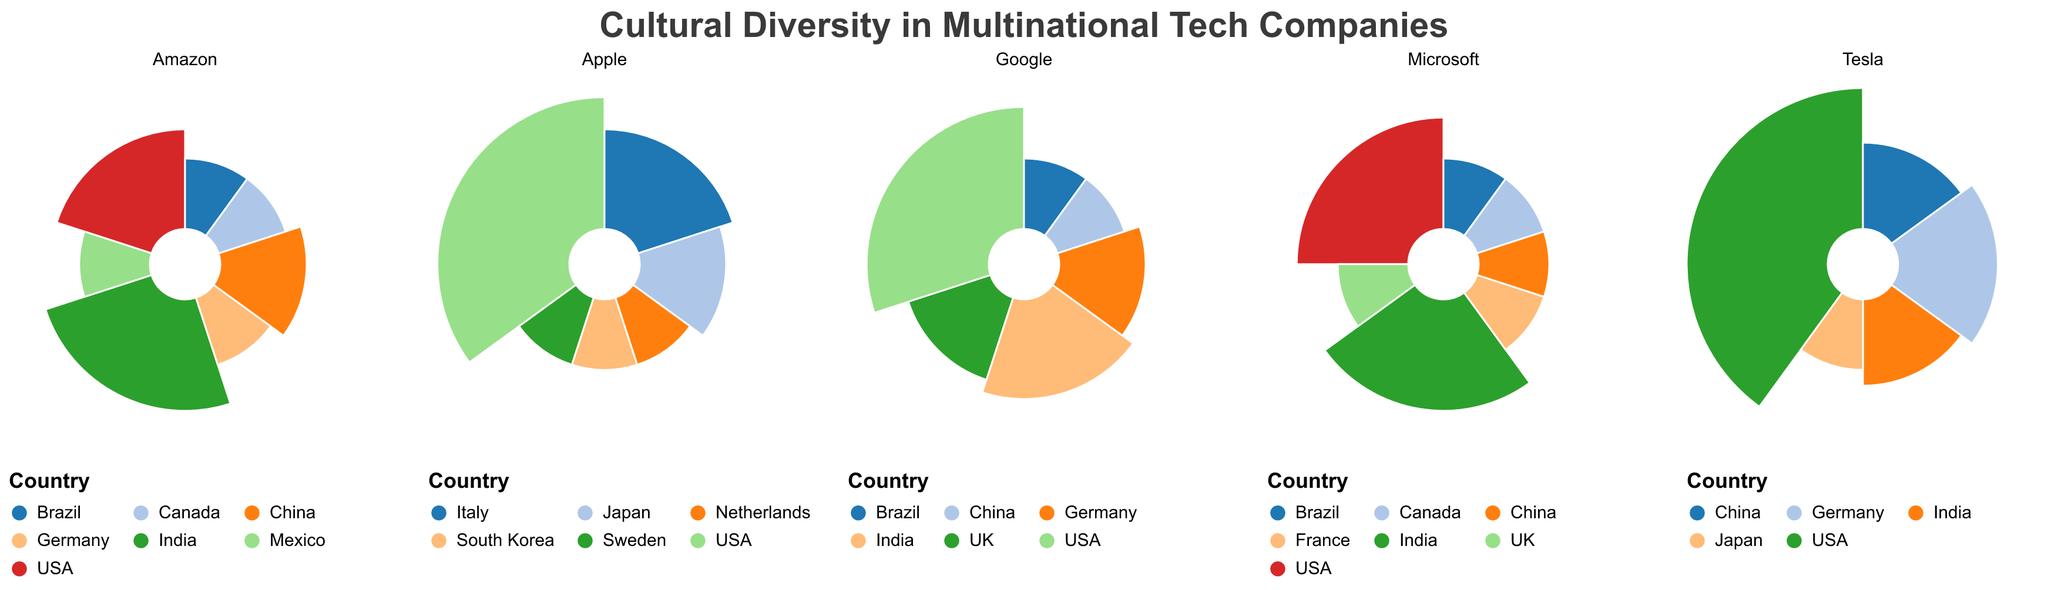What are the different cultural backgrounds represented in Google's Engineering team? The Polar Chart displays segments corresponding to each cultural background in Google's Engineering team. These include contributions from the USA, India, China, Brazil, the UK, and Germany.
Answer: USA, India, China, Brazil, UK, Germany Which company has the highest percentage contribution from the USA? In the Polar Chart, Tesla's Development team has the largest arc segment for the USA, contributing 40%. A simple comparison with the other companies' USA segments confirms this.
Answer: Tesla What is the combined percentage contribution of China and India in Apple's Design team? The chart shows the percentage contributions from China and India in Apple's Design team as 15% and 15% respectively. Adding these values gives the total contribution. 15% + 15% = 30%
Answer: 30% Which company shows a more evenly distributed contribution among different cultural backgrounds, Amazon's Logistics or Microsoft's Research team? By visually inspecting the Polar Charts, Amazon's Logistics shows more segments with smaller and relatively even sizes compared to Microsoft's Research, which has larger contributions from the USA and India, and smaller from other countries.
Answer: Amazon Identify the company and team with the lowest cultural diversity. Tesla's Development team shows a high percentage from the USA (40%), indicating a lower cultural diversity compared to others with smaller and more varied segments.
Answer: Tesla What proportion of Google's Engineering team is made up of contributions from countries other than the USA? Google’s Engineering team consists of 30% from the USA. Subtracting this from 100%, we find 100% - 30% = 70%.
Answer: 70% By how much does the USA's contribution in Amazon's Logistics team exceed that in Microsoft's Research team? The chart shows Amazon's Logistics team has a 20% contribution from the USA, while Microsoft's Research team has 25%. The difference is 25% - 20% = 5%.
Answer: 5% How does the percentage contribution from Germany in Tesla's Development team compare to Google's Engineering team? Looking at the chart, Germany contributes 20% to Tesla's Development team and 15% to Google's Engineering team. Tesla's is higher by 5%, as 20% - 15% = 5%.
Answer: Tesla's is higher by 5% What is the average percentage contribution per country in Apple's Design team? Apple's Design team has six countries with contributions of 35%, 20%, 15%, 10%, 10%, and 10%. Adding these together, 35 + 20 + 15 + 10 + 10 + 10 = 100%, and dividing by six gives an average of 100/6 ≈ 16.67%.
Answer: 16.67% Which two companies have contributions from all represented countries totaling exactly 100%? All companies in the dataset represent totals of 100%, but Apple's Design and Microsoft's Research are easier to distinguish as having even contributions that sum to exactly 100% based on the prominent and varied segments in their charts.
Answer: Apple, Microsoft 